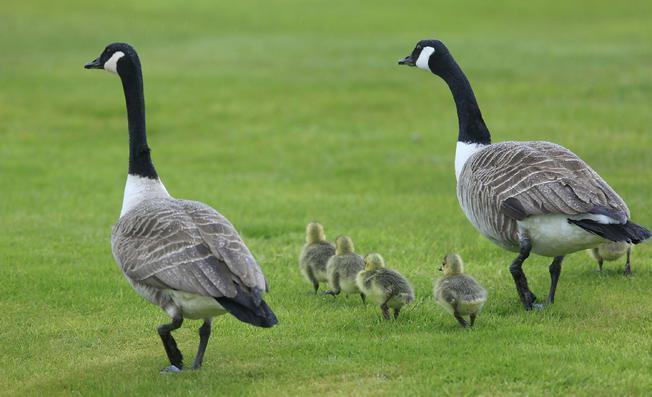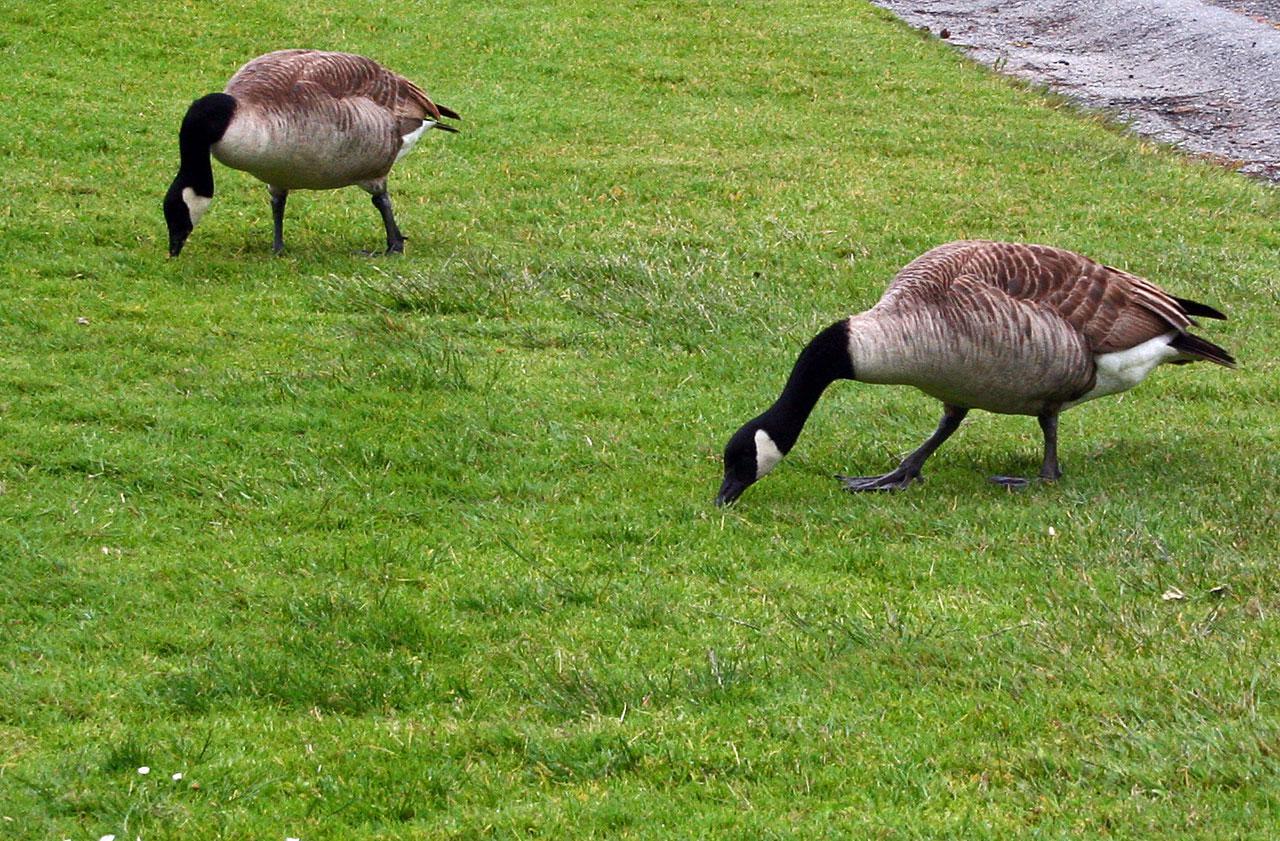The first image is the image on the left, the second image is the image on the right. Evaluate the accuracy of this statement regarding the images: "There are at least two baby geese.". Is it true? Answer yes or no. Yes. The first image is the image on the left, the second image is the image on the right. For the images shown, is this caption "There are a handful of goslings (baby geese) in the left image." true? Answer yes or no. Yes. 